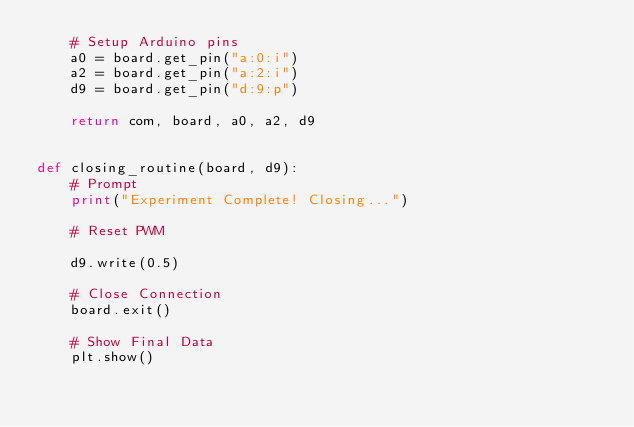Convert code to text. <code><loc_0><loc_0><loc_500><loc_500><_Python_>    # Setup Arduino pins
    a0 = board.get_pin("a:0:i")
    a2 = board.get_pin("a:2:i")
    d9 = board.get_pin("d:9:p")

    return com, board, a0, a2, d9


def closing_routine(board, d9):
    # Prompt
    print("Experiment Complete! Closing...")

    # Reset PWM

    d9.write(0.5)

    # Close Connection
    board.exit()

    # Show Final Data
    plt.show()
</code> 